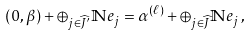<formula> <loc_0><loc_0><loc_500><loc_500>( 0 , \beta ) + \oplus _ { j \in \widehat { J } ^ { \prime } } \mathbb { N } e _ { j } = \alpha ^ { ( \ell ) } + \oplus _ { j \in \widehat { J } } \mathbb { N } e _ { j } \, ,</formula> 